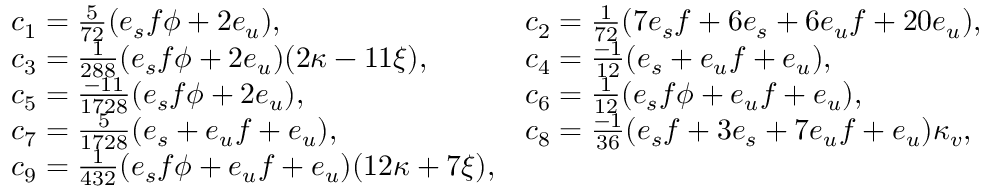Convert formula to latex. <formula><loc_0><loc_0><loc_500><loc_500>\begin{array} { l l } { { c _ { 1 } = { \frac { 5 } { 7 2 } } ( e _ { s } f \phi + 2 e _ { u } ) , } } & { { c _ { 2 } = { \frac { 1 } { 7 2 } } ( 7 e _ { s } f + 6 e _ { s } + 6 e _ { u } f + 2 0 e _ { u } ) , } } \\ { { c _ { 3 } = { \frac { 1 } { 2 8 8 } } ( e _ { s } f \phi + 2 e _ { u } ) ( 2 \kappa - 1 1 \xi ) , } } & { { c _ { 4 } = { \frac { - 1 } { 1 2 } } ( e _ { s } + e _ { u } f + e _ { u } ) , } } \\ { { c _ { 5 } = { \frac { - 1 1 } { 1 7 2 8 } } ( e _ { s } f \phi + 2 e _ { u } ) , } } & { { c _ { 6 } = { \frac { 1 } { 1 2 } } ( e _ { s } f \phi + e _ { u } f + e _ { u } ) , } } \\ { { c _ { 7 } = { \frac { 5 } { 1 7 2 8 } } ( e _ { s } + e _ { u } f + e _ { u } ) , } } & { { c _ { 8 } = { \frac { - 1 } { 3 6 } } ( e _ { s } f + 3 e _ { s } + 7 e _ { u } f + e _ { u } ) \kappa _ { v } , } } \\ { { c _ { 9 } = { \frac { 1 } { 4 3 2 } } ( e _ { s } f \phi + e _ { u } f + e _ { u } ) ( 1 2 \kappa + 7 \xi ) , } } \end{array}</formula> 